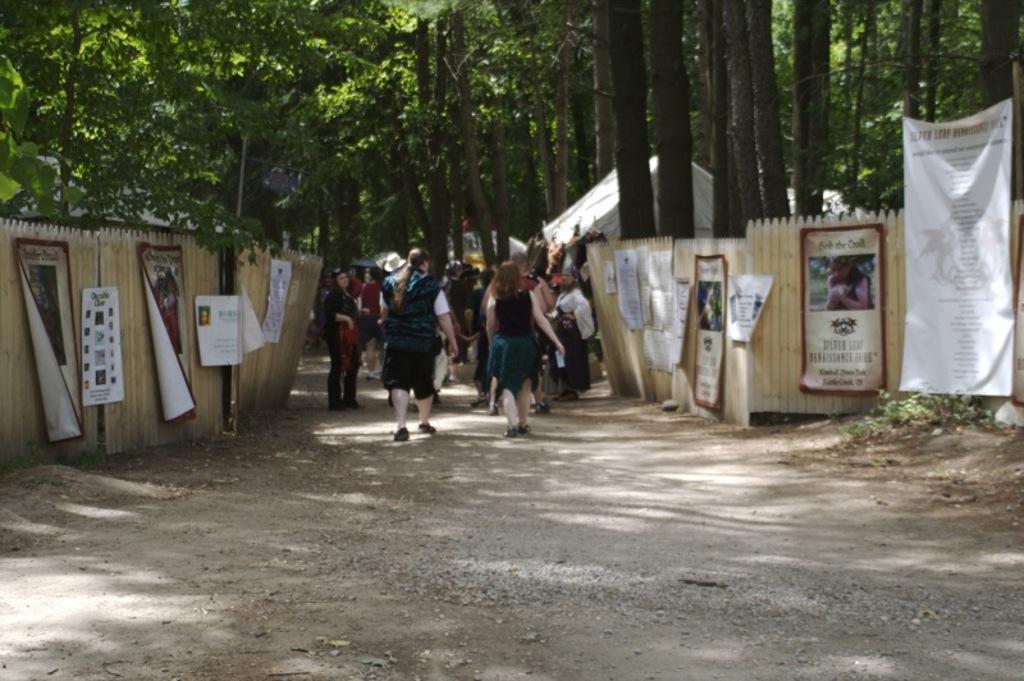Can you describe this image briefly? In this image we can see a group of people standing on the ground. We can also see some stones, plants, some banners on the fence, a tent, a pole, the bark of the trees and a group of trees. 